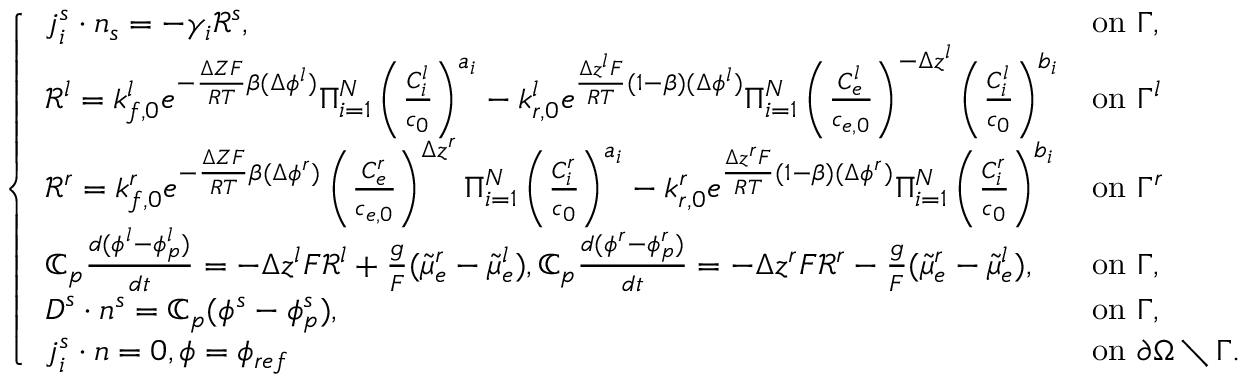Convert formula to latex. <formula><loc_0><loc_0><loc_500><loc_500>\left \{ \begin{array} { l l } { j _ { i } ^ { s } \cdot n _ { s } = - \gamma _ { i } \mathcal { R } ^ { s } , } & { o n \Gamma , } \\ { \mathcal { R } ^ { l } = k _ { f , 0 } ^ { l } e ^ { - \frac { \Delta Z F } { R T } \beta ( \Delta \phi ^ { l } ) } \Pi _ { i = 1 } ^ { N } \left ( \frac { C _ { i } ^ { l } } { c _ { 0 } } \right ) ^ { a _ { i } } - k _ { r , 0 } ^ { l } e ^ { \frac { \Delta z ^ { l } F } { R T } ( 1 - \beta ) ( \Delta \phi ^ { l } ) } \Pi _ { i = 1 } ^ { N } \left ( \frac { C _ { e } ^ { l } } { c _ { e , 0 } } \right ) ^ { - \Delta z ^ { l } } \left ( \frac { C _ { i } ^ { l } } { c _ { 0 } } \right ) ^ { b _ { i } } } & { o n \Gamma ^ { l } } \\ { \mathcal { R } ^ { r } = k _ { f , 0 } ^ { r } e ^ { - \frac { \Delta Z F } { R T } \beta ( \Delta \phi ^ { r } ) } \left ( \frac { C _ { e } ^ { r } } { c _ { e , 0 } } \right ) ^ { \Delta z ^ { r } } \Pi _ { i = 1 } ^ { N } \left ( \frac { C _ { i } ^ { r } } { c _ { 0 } } \right ) ^ { a _ { i } } - k _ { r , 0 } ^ { r } e ^ { \frac { \Delta z ^ { r } F } { R T } ( 1 - \beta ) ( \Delta \phi ^ { r } ) } \Pi _ { i = 1 } ^ { N } \left ( \frac { C _ { i } ^ { r } } { c _ { 0 } } \right ) ^ { b _ { i } } } & { o n \Gamma ^ { r } } \\ { \mathbb { C } _ { p } \frac { d ( \phi ^ { l } - \phi _ { p } ^ { l } ) } { d t } = - \Delta z ^ { l } F \mathcal { R } ^ { l } + \frac { g } F ( \tilde { \mu } _ { e } ^ { r } - \tilde { \mu } _ { e } ^ { l } ) , \mathbb { C } _ { p } \frac { d ( \phi ^ { r } - \phi _ { p } ^ { r } ) } { d t } = - \Delta z ^ { r } F \mathcal { R } ^ { r } - \frac { g } F ( \tilde { \mu } _ { e } ^ { r } - \tilde { \mu } _ { e } ^ { l } ) , } & { o n \Gamma , } \\ { D ^ { s } \cdot n ^ { s } = \mathbb { C } _ { p } ( \phi ^ { s } - \phi _ { p } ^ { s } ) , } & { o n \Gamma , } \\ { j _ { i } ^ { s } \cdot n = 0 , \phi = \phi _ { r e f } } & { o n \partial \Omega \ \Gamma . } \end{array}</formula> 